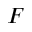<formula> <loc_0><loc_0><loc_500><loc_500>F</formula> 